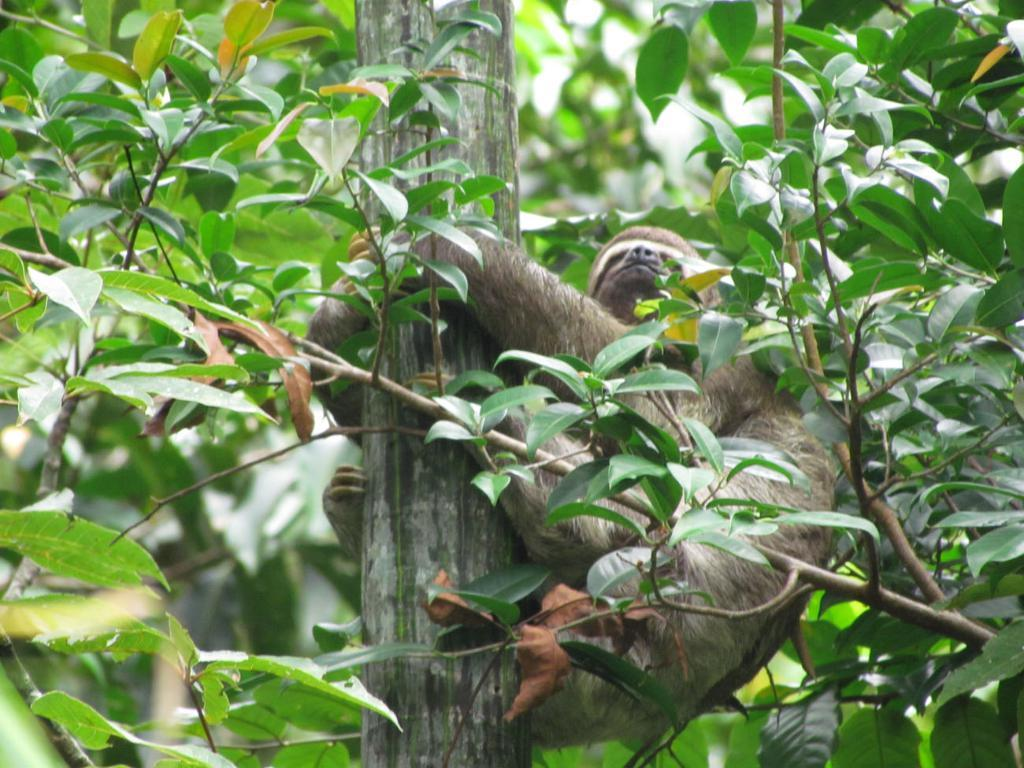What animal can be seen on the right side of the image? There is a monkey on the right side of the image. What is located in the center of the image? There is a bamboo in the center of the image. What type of vegetation is present in the image? There are trees around the area of the image. Is there a volcano erupting in the background of the image? No, there is no volcano present in the image. What type of ink can be seen dripping from the monkey's paw in the image? There is no ink present in the image; it features a monkey, bamboo, and trees. 